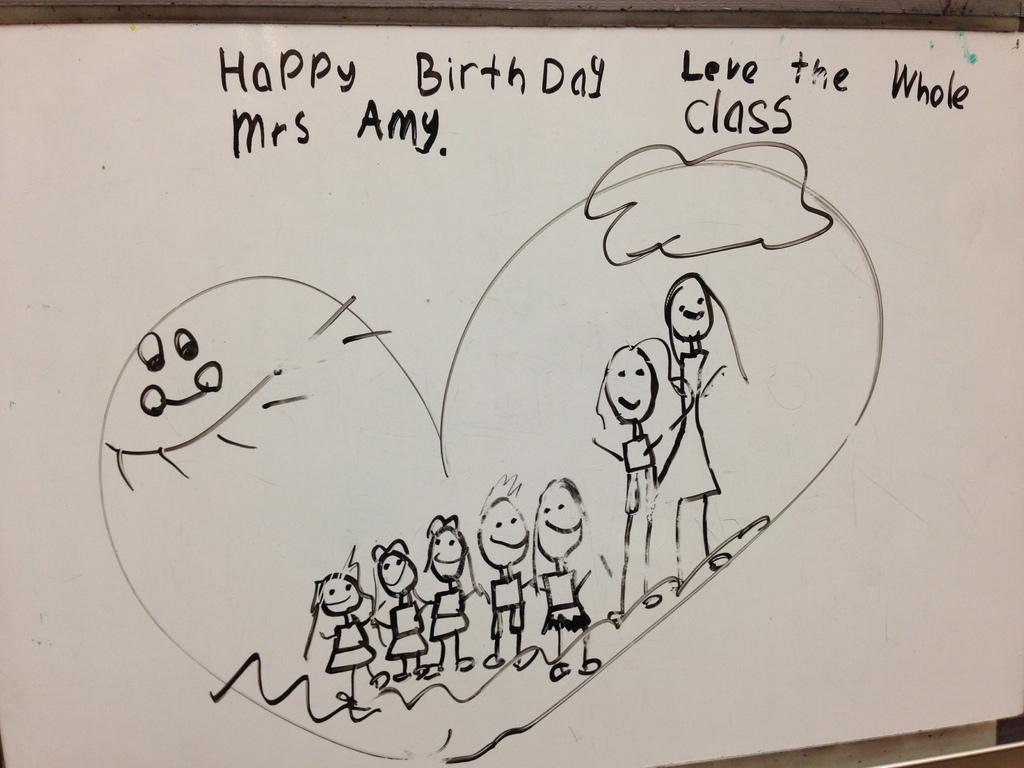Can you describe this image briefly? In the center of the image there is a board on which there is a drawing and some text written on it. 